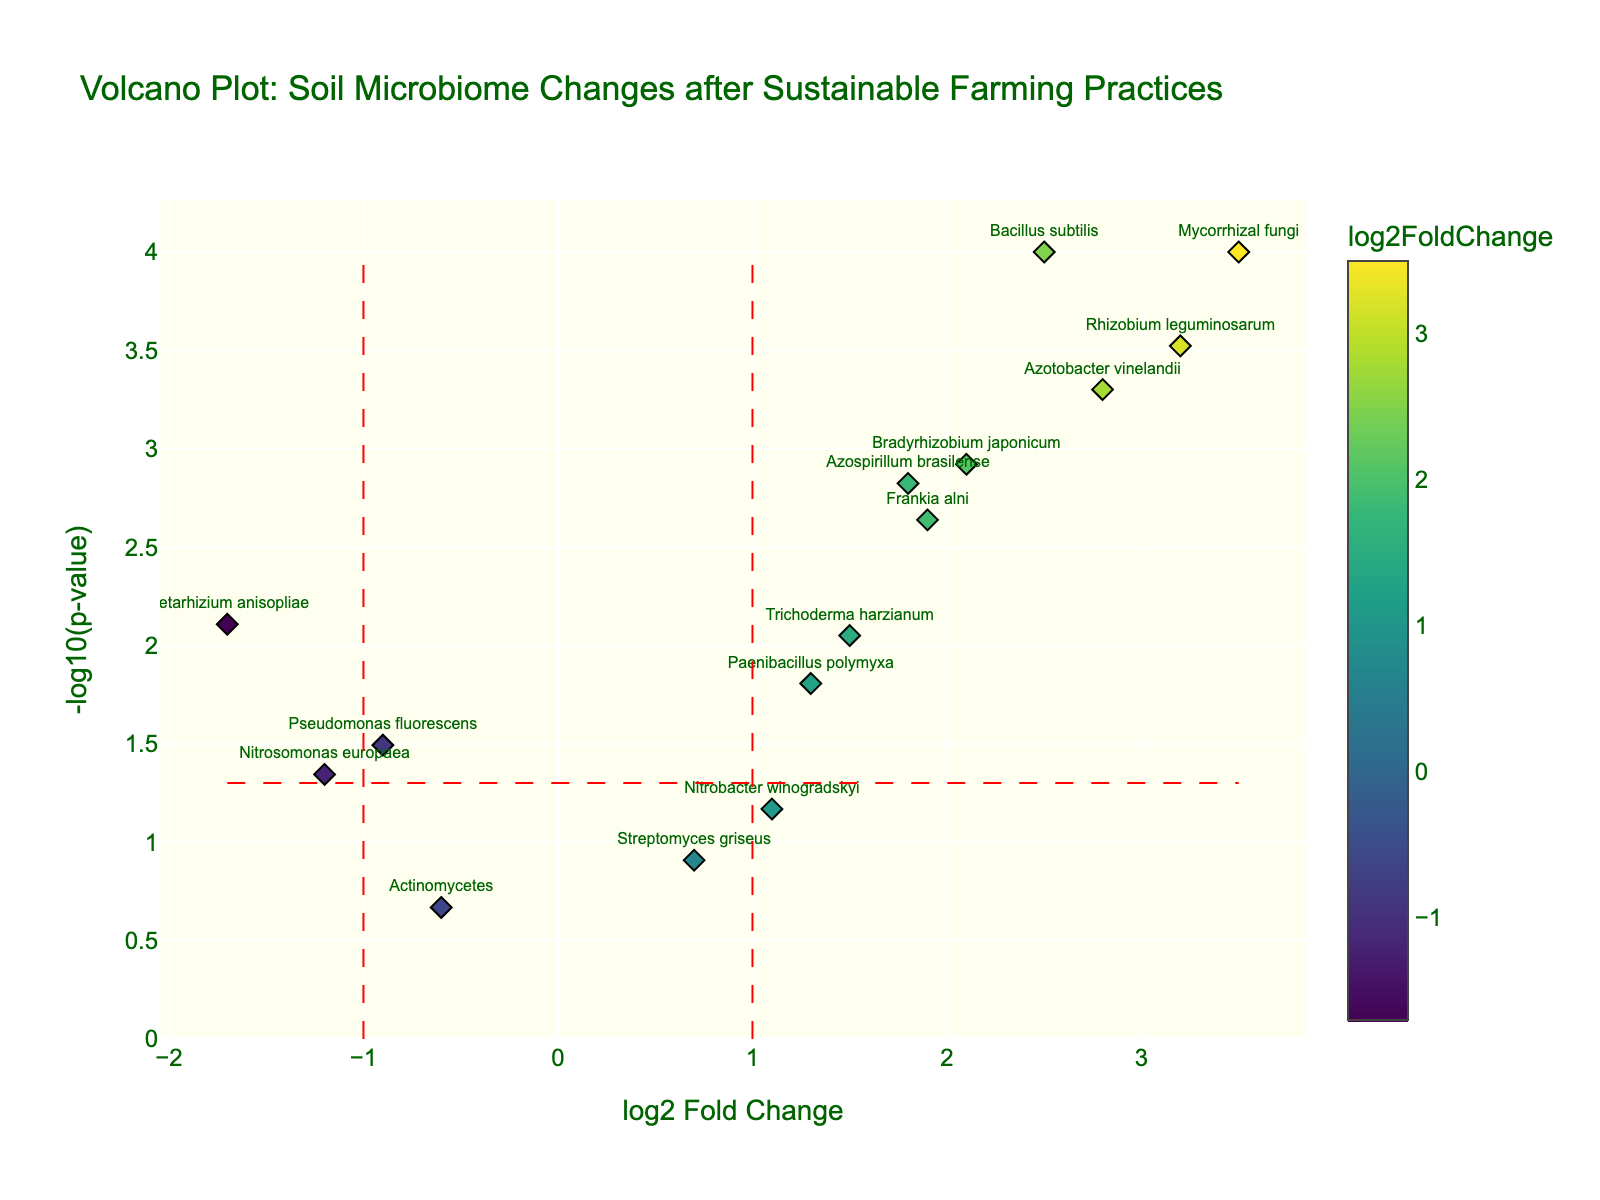What is the title of the plot? The title of the plot is located at the top and is designed to provide a brief description of the figure. Read the title that appears at the top of the plot.
Answer: "Volcano Plot: Soil Microbiome Changes after Sustainable Farming Practices" What does the x-axis represent? The x-axis title is a label that usually describes what the horizontal axis measures. Here, it is written directly on the plot.
Answer: "log2 Fold Change" What organism has the highest log2 fold change? To find the organism with the highest log2 fold change, look at the data points along the x-axis and identify the one furthest to the right.
Answer: "Mycorrhizal fungi" How many organisms have a log2 fold change greater than 1.5? Count the number of data points to the right of the x-axis mark of 1.5. These represent organisms where the log2 fold change is greater than 1.5.
Answer: 7 Is Bacillus subtilis significantly affected by the sustainable farming practices? Significant changes can be inferred from data points with a p-value lower than 0.05 (i.e., higher than -log10(0.05) on the y-axis) and a log2 fold change magnitude greater than 1. Bacillus subtilis has a high log2 fold change and p-value less than 0.05.
Answer: Yes Which organism shows the most significant decrease in abundance after implementing sustainable farming practices? Look at the data points with a log2 fold change less than 0 (suggesting a decrease) and high on the y-axis (indicating low p-value). Identify the organism that has the lowest log2 fold change to see the most significant decrease.
Answer: "Metarhizium anisopliae" Compare the significance levels between Rhizobium leguminosarum and Azotobacter vinelandii. Which one is more significant? Compare the -log10(p-value) on the y-axis for both Rhizobium leguminosarum and Azotobacter vinelandii. The organism with the higher -log10(p-value) is more significant.
Answer: "Rhizobium leguminosarum" Which data point has the smallest p-value and what organism does it correspond to? The smallest p-value corresponds to the highest -log10(p-value). Identify the highest point on the y-axis and its corresponding organism.
Answer: "Mycorrhizal fungi" What is the threshold for significance in the p-value, and how is it represented in the plot? The significance threshold for p-value in the plot is usually set at 0.05. This is depicted as a horizontal dashed line marking -log10(0.05) on the y-axis.
Answer: -log10(0.05) shown with a red dashed line on the y-axis 